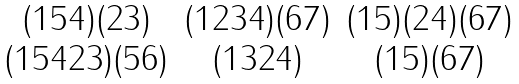Convert formula to latex. <formula><loc_0><loc_0><loc_500><loc_500>\begin{matrix} ( 1 5 4 ) ( 2 3 ) & ( 1 2 3 4 ) ( 6 7 ) & ( 1 5 ) ( 2 4 ) ( 6 7 ) \\ ( 1 5 4 2 3 ) ( 5 6 ) & ( 1 3 2 4 ) & ( 1 5 ) ( 6 7 ) \end{matrix}</formula> 